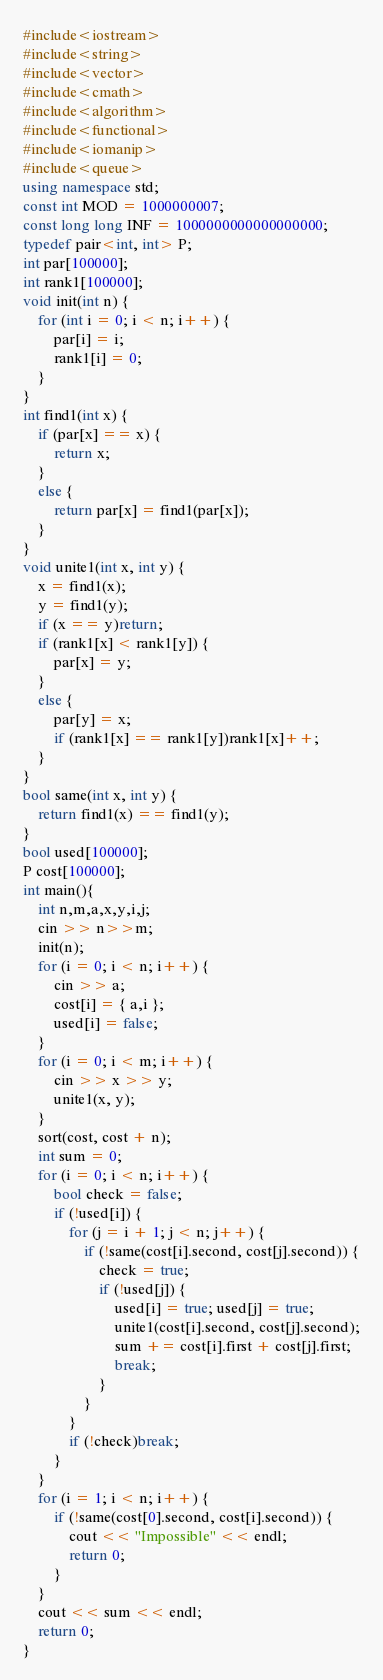<code> <loc_0><loc_0><loc_500><loc_500><_C++_>#include<iostream>
#include<string>
#include<vector>
#include<cmath>
#include<algorithm>
#include<functional>
#include<iomanip>
#include<queue>
using namespace std;
const int MOD = 1000000007;
const long long INF = 1000000000000000000;
typedef pair<int, int> P;
int par[100000];
int rank1[100000];
void init(int n) {
	for (int i = 0; i < n; i++) {
		par[i] = i;
		rank1[i] = 0;
	}
}
int find1(int x) {
	if (par[x] == x) {
		return x;
	}
	else {
		return par[x] = find1(par[x]);
	}
}
void unite1(int x, int y) {
	x = find1(x);
	y = find1(y);
	if (x == y)return;
	if (rank1[x] < rank1[y]) {
		par[x] = y;
	}
	else {
		par[y] = x;
		if (rank1[x] == rank1[y])rank1[x]++;
	}
}
bool same(int x, int y) {
	return find1(x) == find1(y);
}
bool used[100000];
P cost[100000];
int main(){
	int n,m,a,x,y,i,j;
	cin >> n>>m;
	init(n);
	for (i = 0; i < n; i++) {
		cin >> a;
		cost[i] = { a,i };
		used[i] = false;
	}
	for (i = 0; i < m; i++) {
		cin >> x >> y;
		unite1(x, y);
	}
	sort(cost, cost + n);
	int sum = 0;
	for (i = 0; i < n; i++) {
		bool check = false;
		if (!used[i]) {
			for (j = i + 1; j < n; j++) {
				if (!same(cost[i].second, cost[j].second)) {
					check = true;
					if (!used[j]) {
						used[i] = true; used[j] = true;
						unite1(cost[i].second, cost[j].second);
						sum += cost[i].first + cost[j].first;
						break;
					}
				}
			}
			if (!check)break;
		}
	}
	for (i = 1; i < n; i++) {
		if (!same(cost[0].second, cost[i].second)) {
			cout << "Impossible" << endl;
			return 0;
		}
	}
	cout << sum << endl;
	return 0;
}</code> 